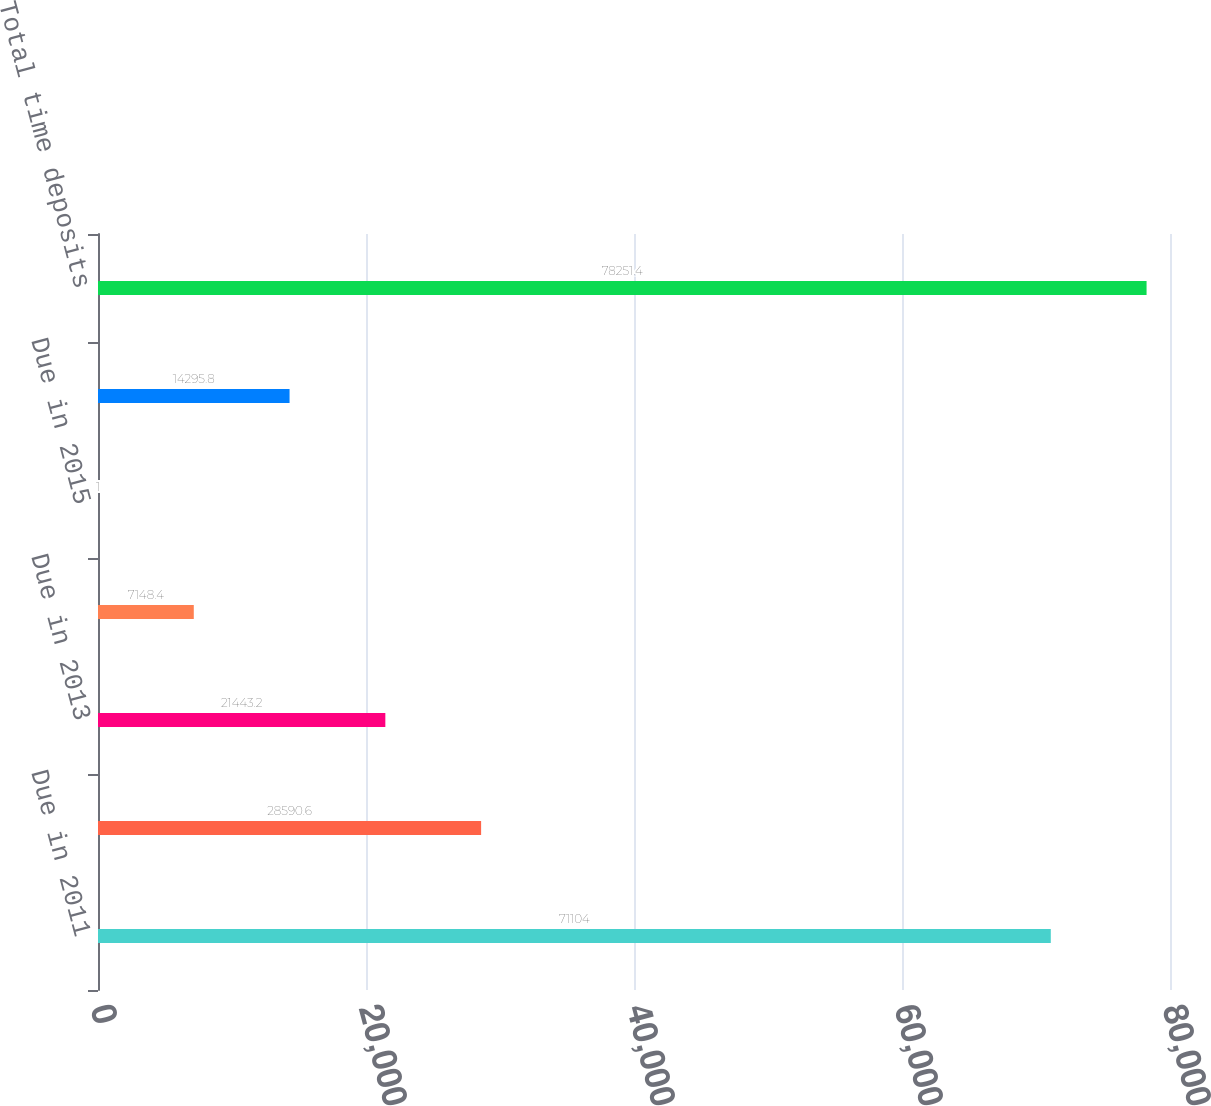Convert chart to OTSL. <chart><loc_0><loc_0><loc_500><loc_500><bar_chart><fcel>Due in 2011<fcel>Due in 2012<fcel>Due in 2013<fcel>Due in 2014<fcel>Due in 2015<fcel>Thereafter<fcel>Total time deposits<nl><fcel>71104<fcel>28590.6<fcel>21443.2<fcel>7148.4<fcel>1<fcel>14295.8<fcel>78251.4<nl></chart> 